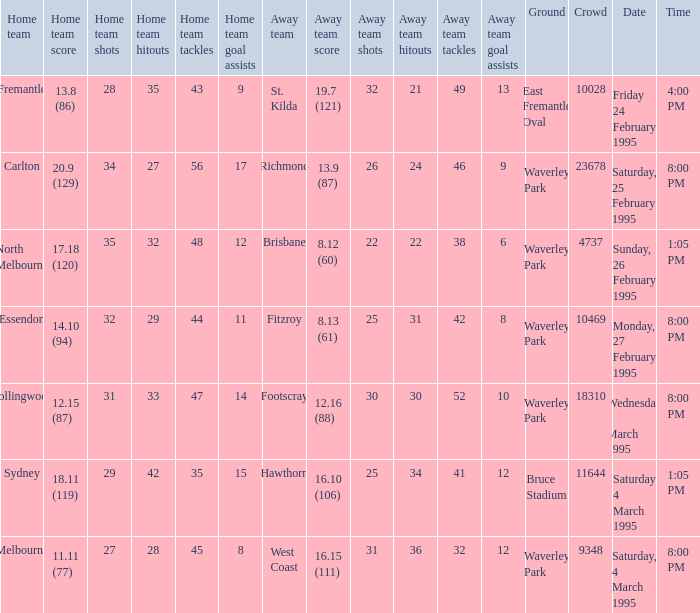Name the time for saturday 4 march 1995 1:05 PM. 